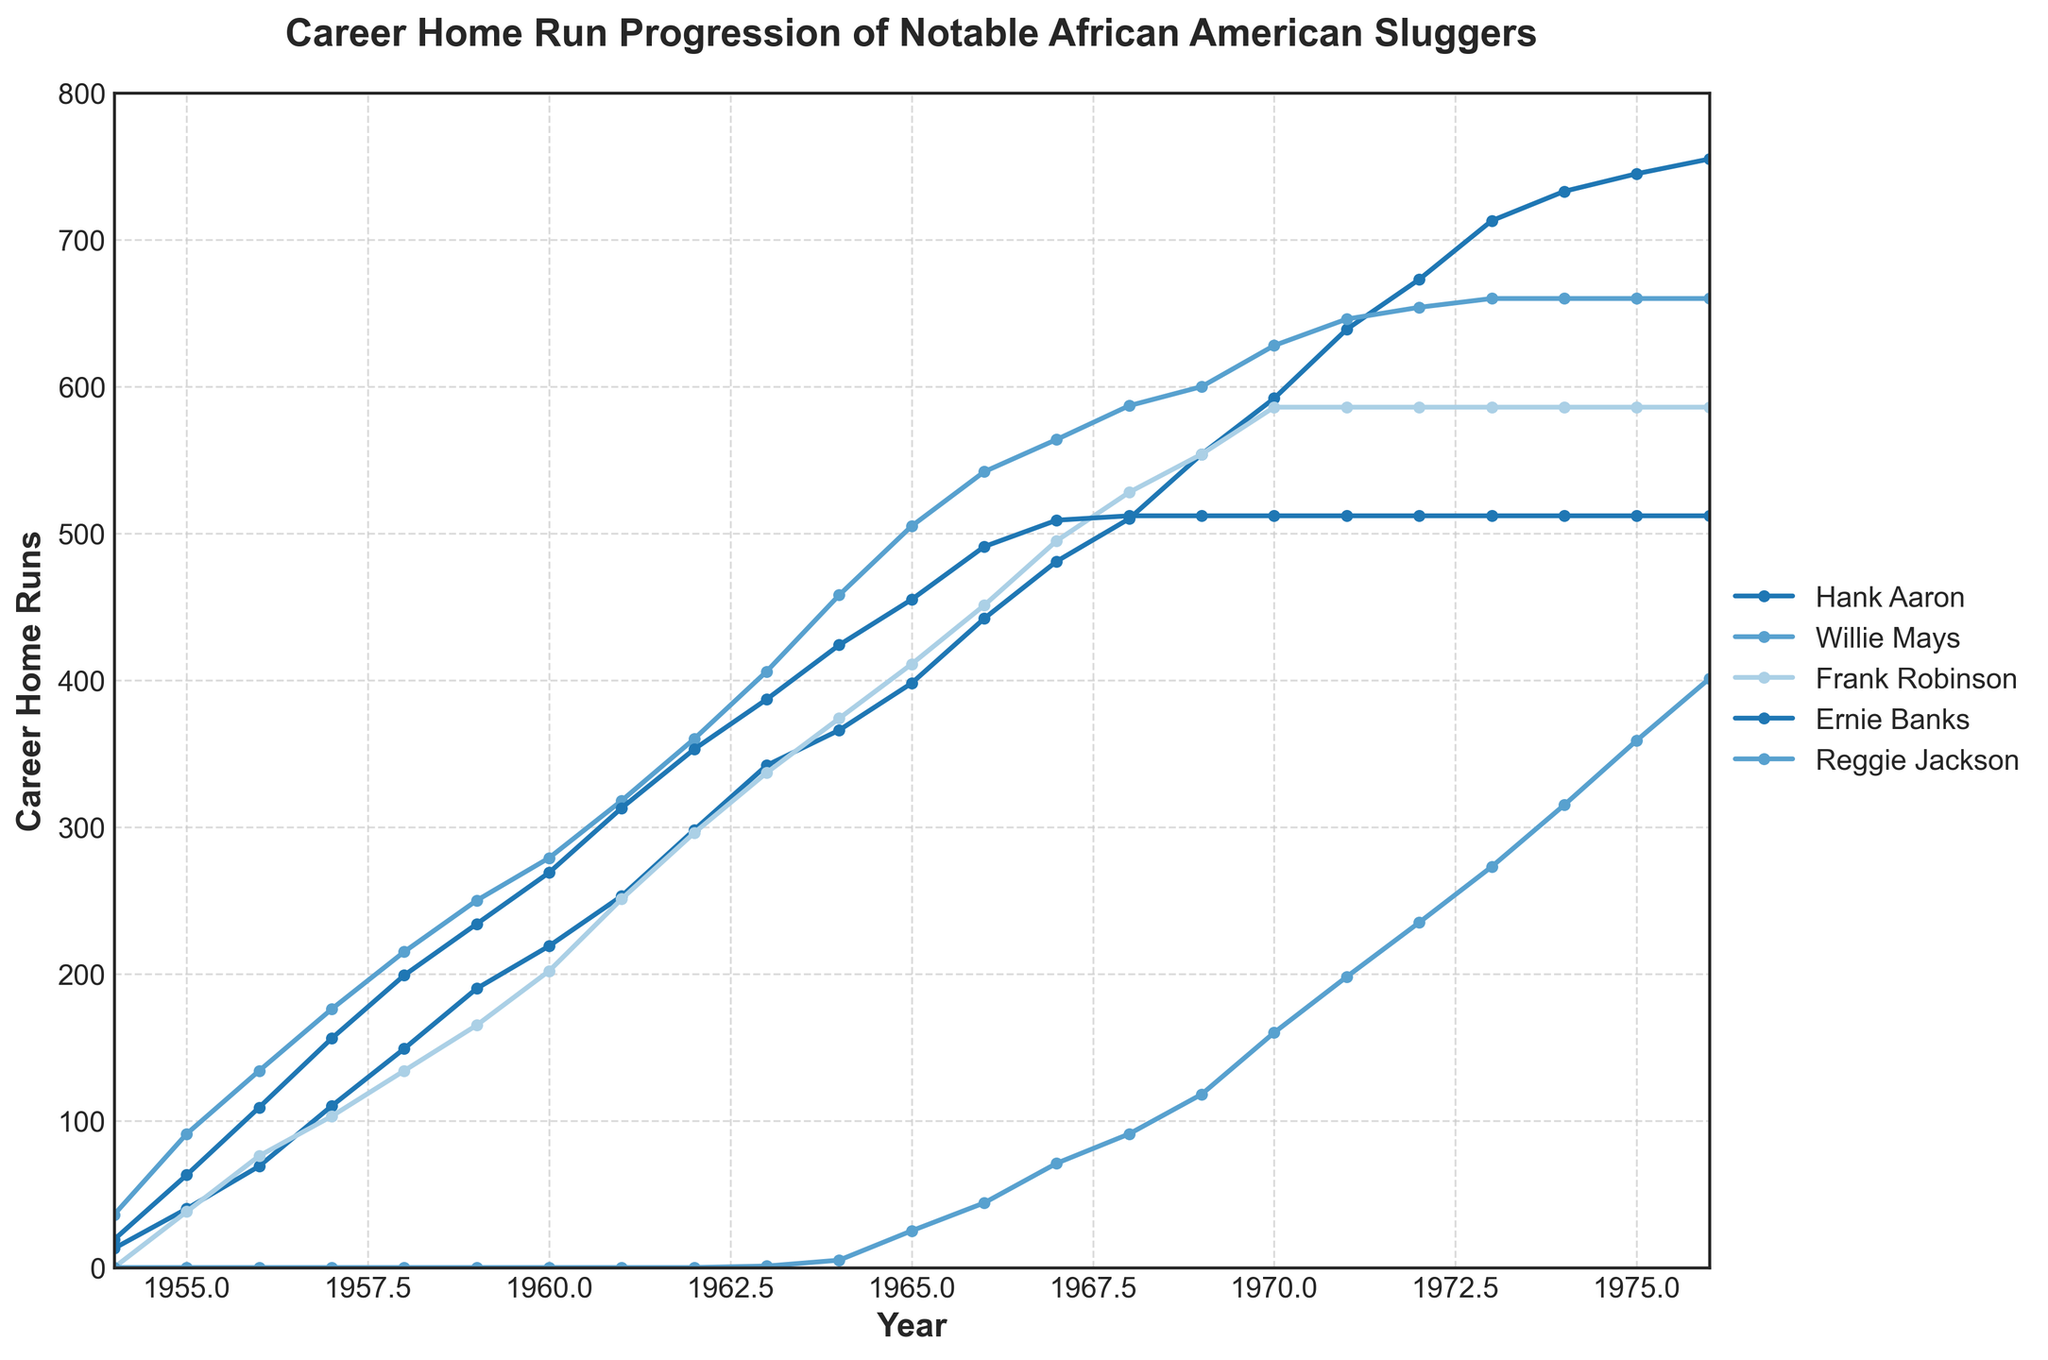Which player's home run total remained the same from 1972 to 1976? The player's home run total that didn't change from 1972 to 1976 is found by observing whose line is flat during those years. In this case, only Frank Robinson and Ernie Banks' home run totals remained constant at 586 and 512, respectively.
Answer: Frank Robinson and Ernie Banks Which player had the most significant increase in home runs between 1954 and 1955? By comparing the slopes of the lines between 1954 and 1955, we see that Willie Mays had the steepest line, indicating the most significant increase in home runs from 36 to 91, an increase of 55.
Answer: Willie Mays In which year did Hank Aaron surpass 500 career home runs? Look for the point on Hank Aaron's line where the home runs exceed 500. Checking the year labels, he surpassed 500 in 1968.
Answer: 1968 How many years did it take for Ernie Banks to reach 400 home runs from his first recorded home runs in 1954? Ernie Banks reached over 400 home runs in 1963, starting in 1954. So, it took from 1954 to 1963, which is 1963 - 1954 = 9 years.
Answer: 9 years Who had more home runs by the year 1970, Reggie Jackson or Ernie Banks? Compare the values of the home runs for Reggie Jackson and Ernie Banks in 1970 by following their respective lines. Ernie Banks had 512 home runs, while Reggie Jackson had 118 in 1970.
Answer: Ernie Banks Did any player reach 600 home runs by 1970? If so, who? By checking the lines for each player by the year 1970, we see that both Hank Aaron (610) and Willie Mays (600) reached at least 600 home runs by this year.
Answer: Hank Aaron and Willie Mays By how much did Hank Aaron's home run total increase from 1965 to 1970? Hank Aaron's home runs in 1965 were 398, and in 1970 they were 624. The increase is 624 - 398 = 226.
Answer: 226 Which player's home run totals appeared to stabilize after 1971? By the flat lines from 1971 onwards, we can see that both Frank Robinson and Ernie Banks did not add to their home run totals, stabilizing at 586 and 512, respectively.
Answer: Frank Robinson and Ernie Banks At what year did Willie Mays' home run total plateau? Observing Willie Mays’ line, it plateaus (remains constant) after 1972 with a total of 660 home runs.
Answer: 1972 